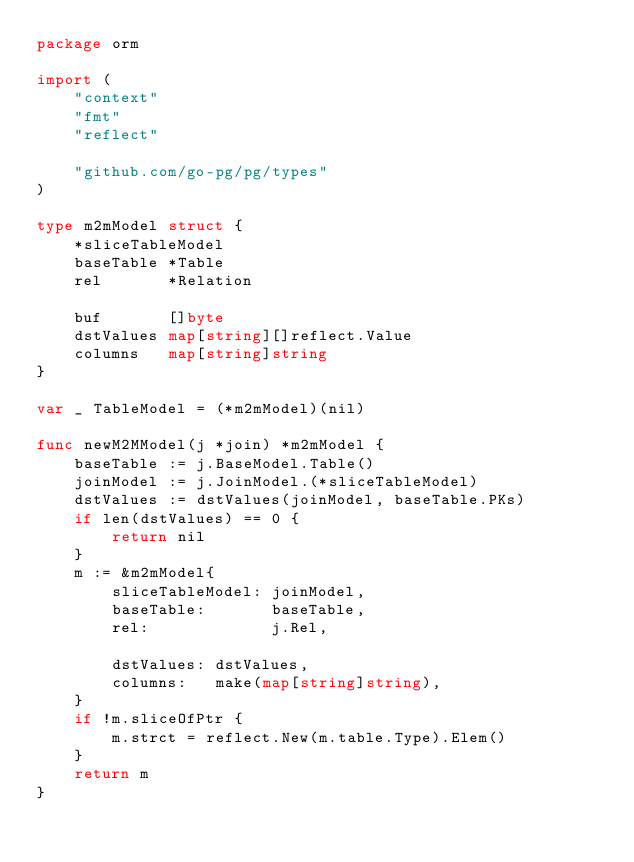<code> <loc_0><loc_0><loc_500><loc_500><_Go_>package orm

import (
	"context"
	"fmt"
	"reflect"

	"github.com/go-pg/pg/types"
)

type m2mModel struct {
	*sliceTableModel
	baseTable *Table
	rel       *Relation

	buf       []byte
	dstValues map[string][]reflect.Value
	columns   map[string]string
}

var _ TableModel = (*m2mModel)(nil)

func newM2MModel(j *join) *m2mModel {
	baseTable := j.BaseModel.Table()
	joinModel := j.JoinModel.(*sliceTableModel)
	dstValues := dstValues(joinModel, baseTable.PKs)
	if len(dstValues) == 0 {
		return nil
	}
	m := &m2mModel{
		sliceTableModel: joinModel,
		baseTable:       baseTable,
		rel:             j.Rel,

		dstValues: dstValues,
		columns:   make(map[string]string),
	}
	if !m.sliceOfPtr {
		m.strct = reflect.New(m.table.Type).Elem()
	}
	return m
}
</code> 